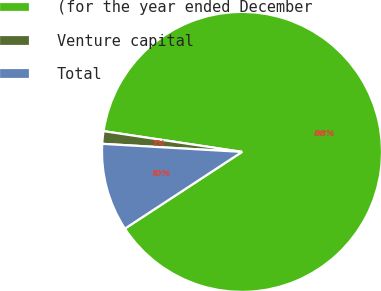Convert chart to OTSL. <chart><loc_0><loc_0><loc_500><loc_500><pie_chart><fcel>(for the year ended December<fcel>Venture capital<fcel>Total<nl><fcel>88.4%<fcel>1.45%<fcel>10.15%<nl></chart> 